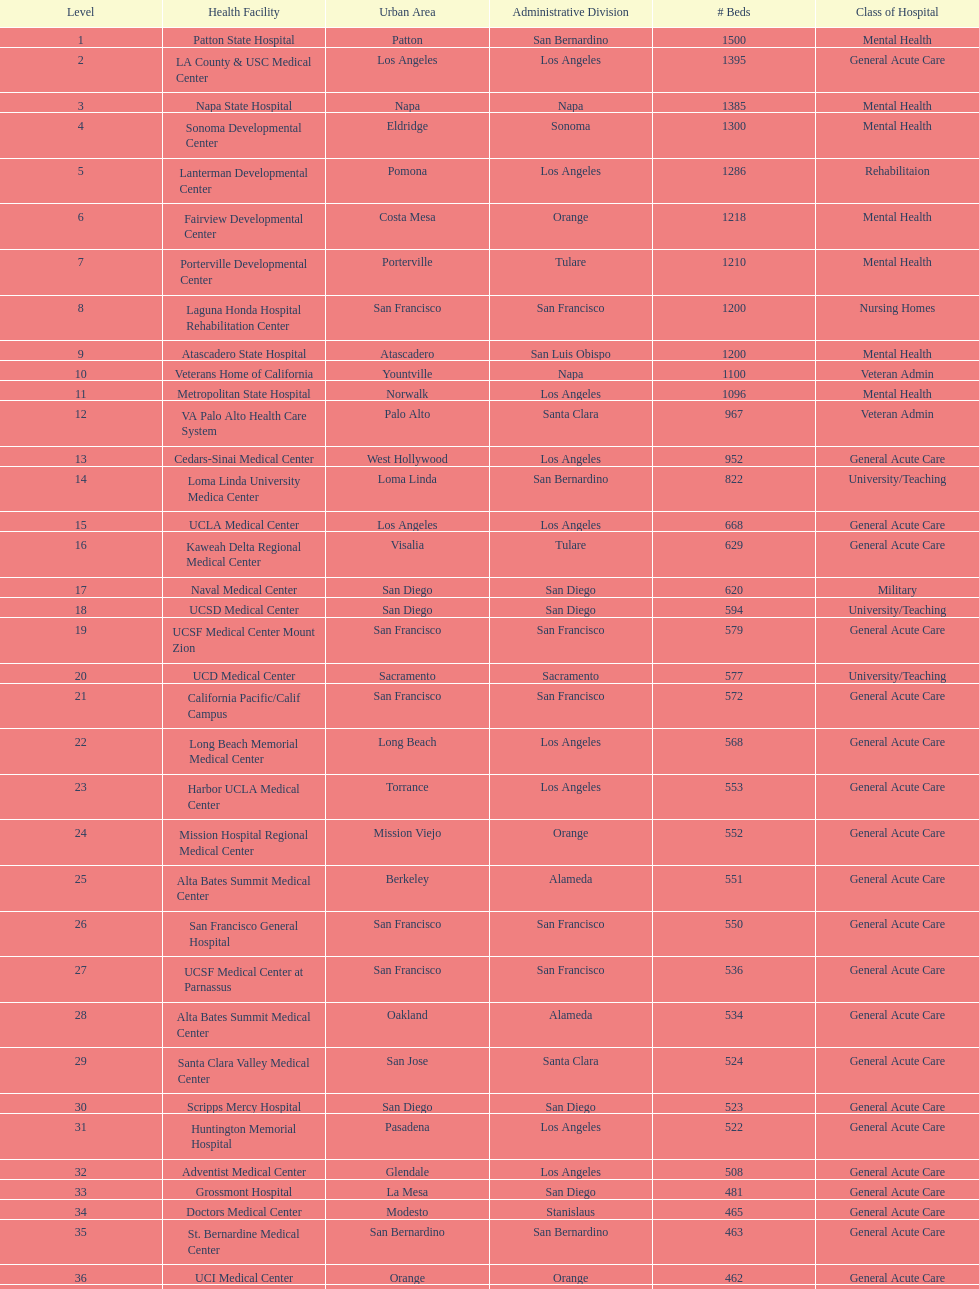By how many beds did the largest hospital in california exceed the size of the 50th largest hospital? 1071. 